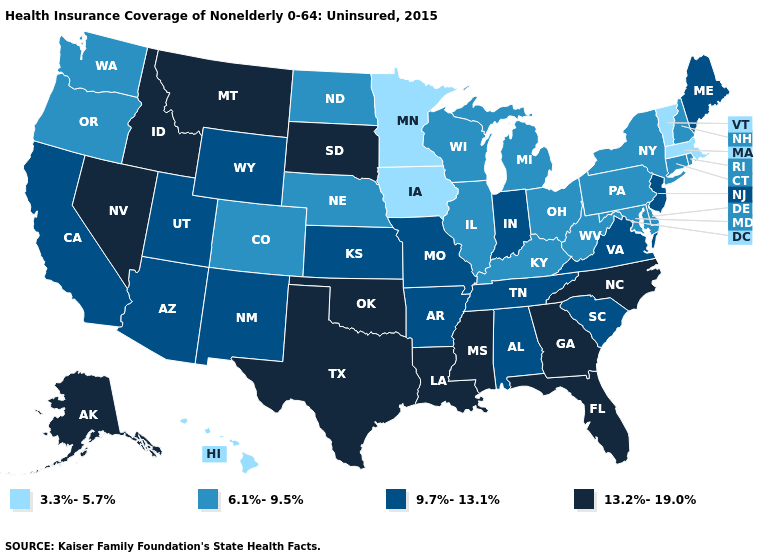What is the highest value in the West ?
Write a very short answer. 13.2%-19.0%. Does Kansas have the highest value in the MidWest?
Answer briefly. No. Does Idaho have the highest value in the West?
Keep it brief. Yes. What is the value of Illinois?
Be succinct. 6.1%-9.5%. What is the value of Nevada?
Keep it brief. 13.2%-19.0%. Does the first symbol in the legend represent the smallest category?
Keep it brief. Yes. What is the lowest value in the South?
Short answer required. 6.1%-9.5%. What is the value of Delaware?
Keep it brief. 6.1%-9.5%. What is the value of Nevada?
Be succinct. 13.2%-19.0%. What is the value of Florida?
Quick response, please. 13.2%-19.0%. Name the states that have a value in the range 9.7%-13.1%?
Concise answer only. Alabama, Arizona, Arkansas, California, Indiana, Kansas, Maine, Missouri, New Jersey, New Mexico, South Carolina, Tennessee, Utah, Virginia, Wyoming. Name the states that have a value in the range 6.1%-9.5%?
Answer briefly. Colorado, Connecticut, Delaware, Illinois, Kentucky, Maryland, Michigan, Nebraska, New Hampshire, New York, North Dakota, Ohio, Oregon, Pennsylvania, Rhode Island, Washington, West Virginia, Wisconsin. Name the states that have a value in the range 13.2%-19.0%?
Quick response, please. Alaska, Florida, Georgia, Idaho, Louisiana, Mississippi, Montana, Nevada, North Carolina, Oklahoma, South Dakota, Texas. What is the value of Alabama?
Give a very brief answer. 9.7%-13.1%. What is the highest value in the USA?
Concise answer only. 13.2%-19.0%. 